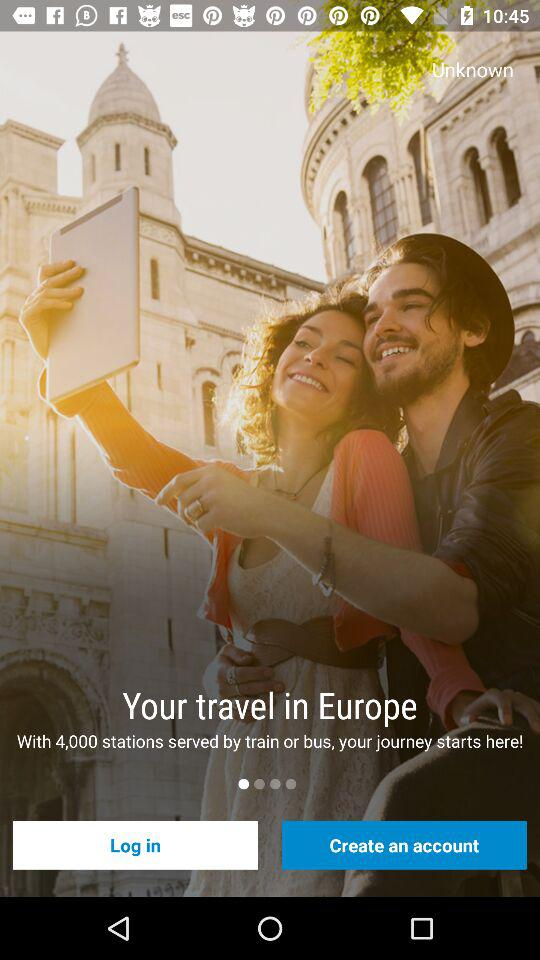How many train and bus stations are there? There are 4,000 stations. 